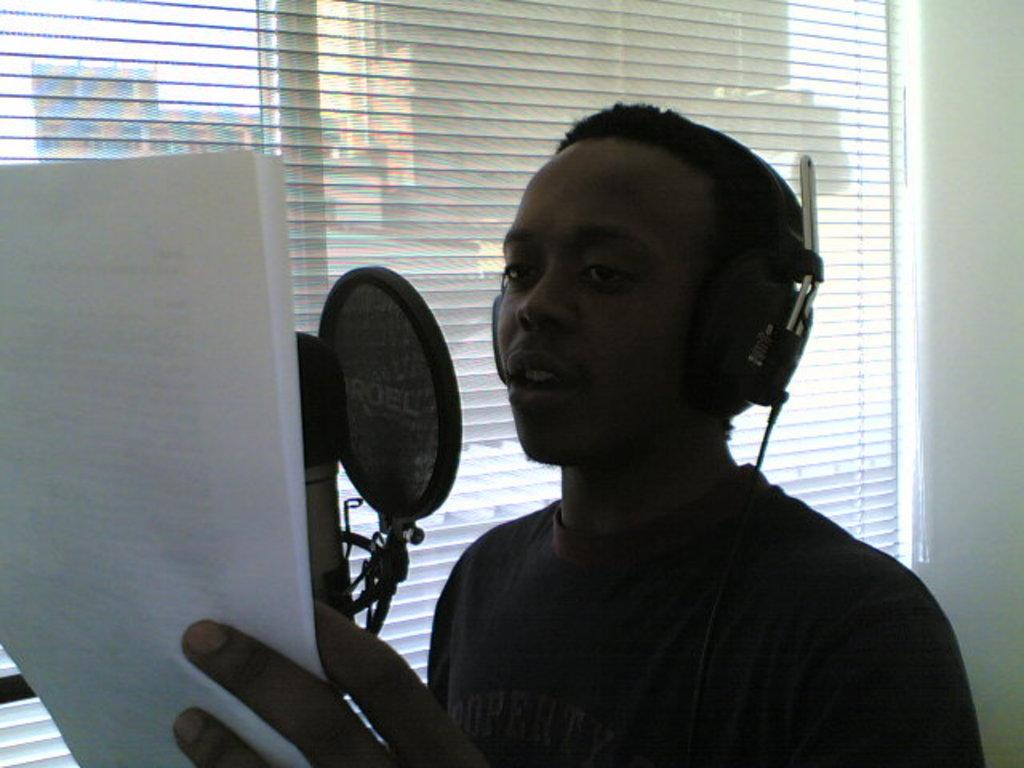What is the main subject in the foreground of the image? There is a man in the foreground of the image. What is the man wearing? The man is wearing a headset. What is the man holding in the image? The man is holding a paper. What is the man standing in front of? The man is in front of a microphone net. Can you describe the microphone in the image? There is a microphone in the image. What can be seen in the background of the image? There is a window blind and a wall visible in the background of the image. What type of haircut is the police officer giving to the man in the image? There is no police officer or haircut present in the image. What type of camp can be seen in the background of the image? There is no camp visible in the image; it features a man in front of a microphone net with a wall and window blind in the background. 